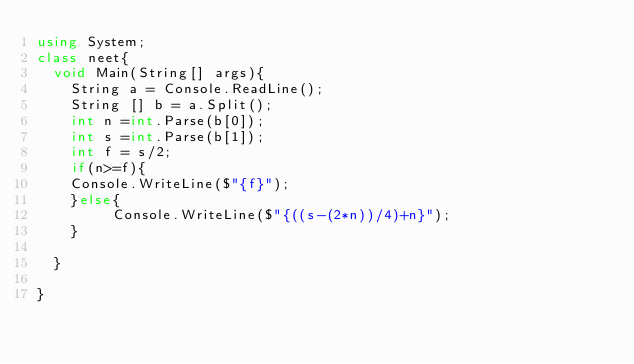Convert code to text. <code><loc_0><loc_0><loc_500><loc_500><_C#_>using System;
class neet{
  void Main(String[] args){
    String a = Console.ReadLine();
    String [] b = a.Split();
    int n =int.Parse(b[0]);
    int s =int.Parse(b[1]);
    int f = s/2;
    if(n>=f){
    Console.WriteLine($"{f}");
    }else{
         Console.WriteLine($"{((s-(2*n))/4)+n}");
    }
 
  }

}
</code> 